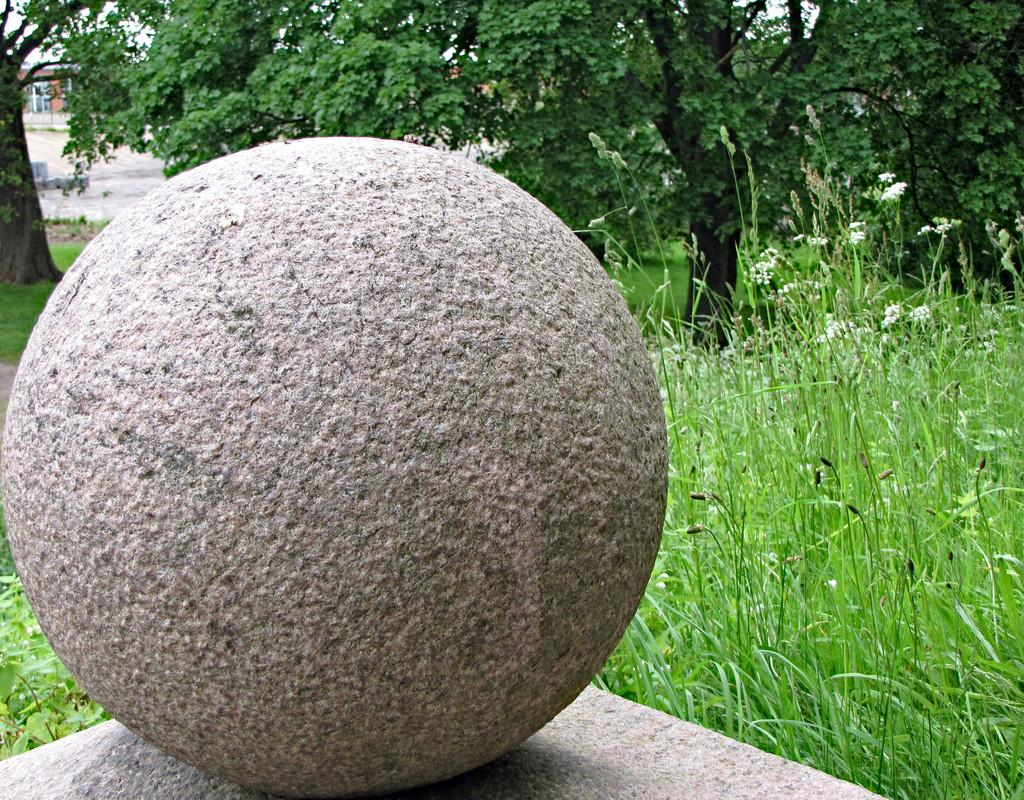What shape is the main object in the image? The main object in the image is round. What is the round object resting on? The round object is on another object. What type of natural environment is visible in the image? There is grass visible in the image. What can be seen in the distance in the image? There are trees and a building in the background of the image. What type of jewel is being discovered by the finger in the image? There is no finger or jewel present in the image. 